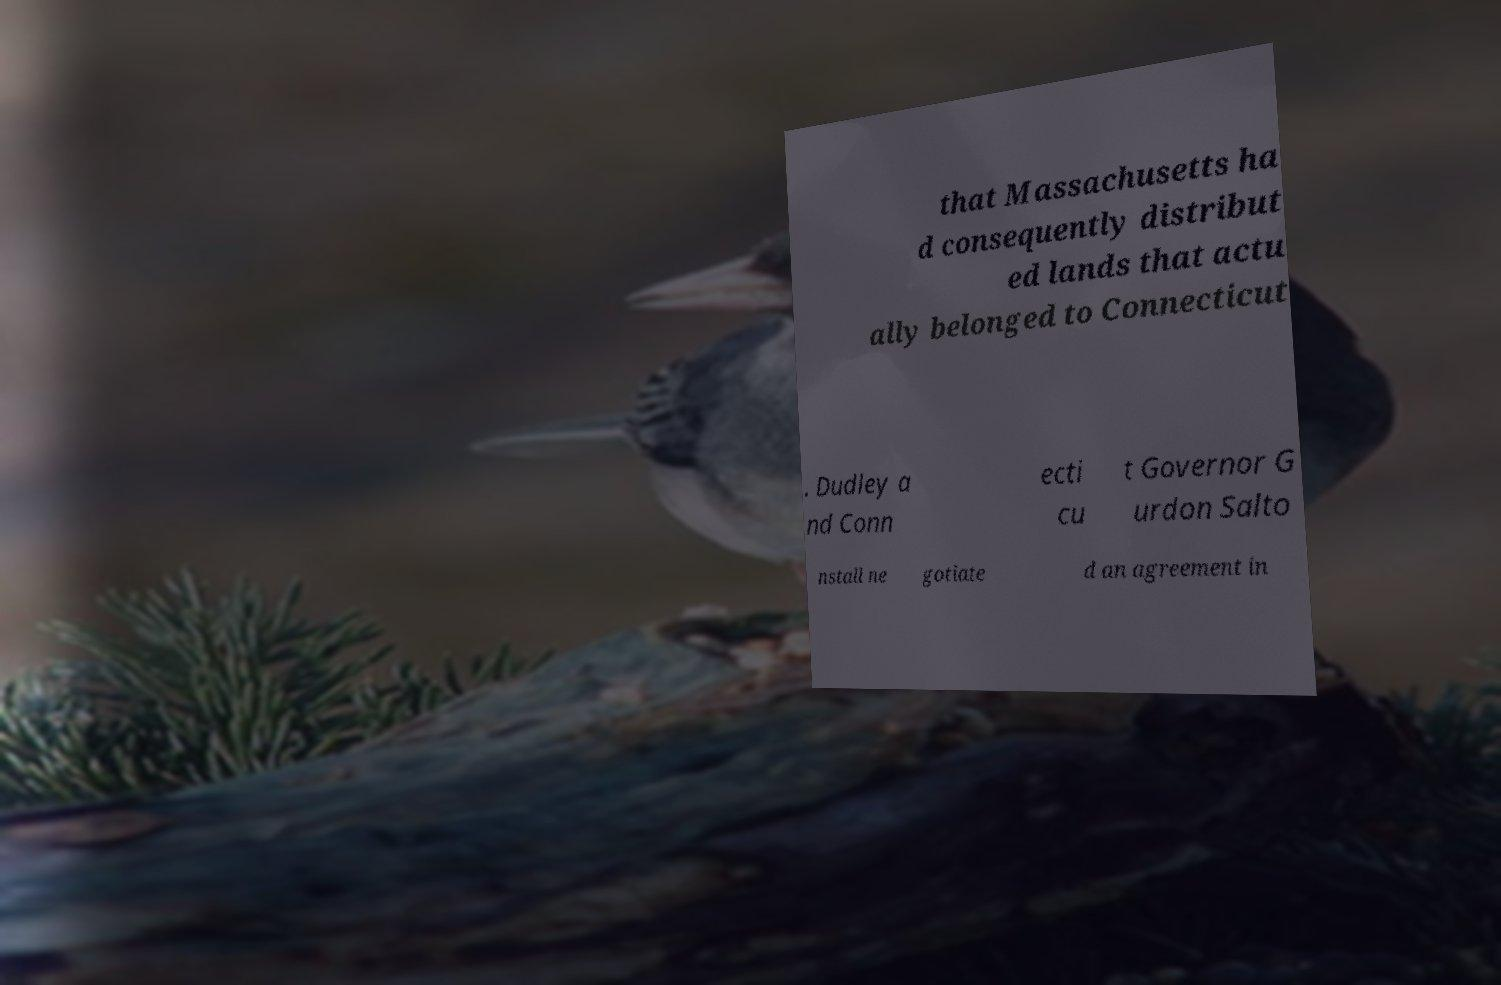For documentation purposes, I need the text within this image transcribed. Could you provide that? that Massachusetts ha d consequently distribut ed lands that actu ally belonged to Connecticut . Dudley a nd Conn ecti cu t Governor G urdon Salto nstall ne gotiate d an agreement in 